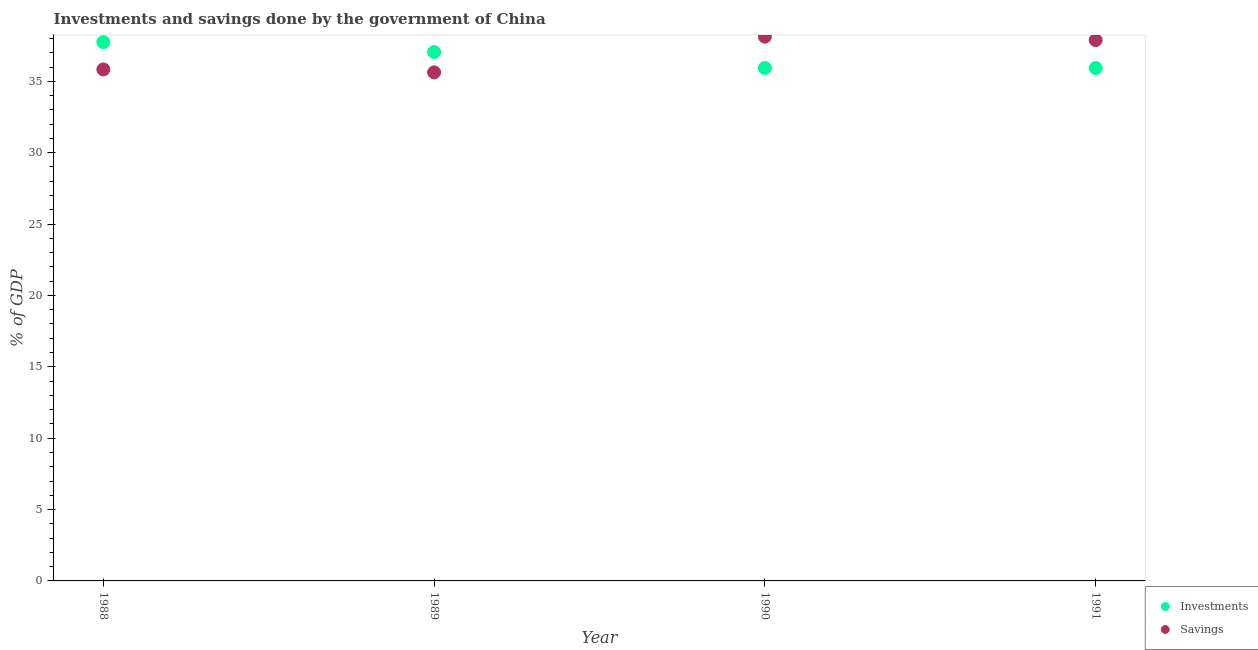What is the investments of government in 1988?
Keep it short and to the point. 37.75. Across all years, what is the maximum investments of government?
Keep it short and to the point. 37.75. Across all years, what is the minimum investments of government?
Provide a short and direct response. 35.93. In which year was the savings of government maximum?
Offer a very short reply. 1990. What is the total savings of government in the graph?
Ensure brevity in your answer.  147.48. What is the difference between the savings of government in 1989 and that in 1990?
Keep it short and to the point. -2.5. What is the difference between the savings of government in 1989 and the investments of government in 1990?
Make the answer very short. -0.31. What is the average investments of government per year?
Offer a very short reply. 36.67. In the year 1988, what is the difference between the investments of government and savings of government?
Make the answer very short. 1.91. In how many years, is the savings of government greater than 24 %?
Offer a terse response. 4. What is the ratio of the investments of government in 1988 to that in 1991?
Provide a succinct answer. 1.05. Is the savings of government in 1989 less than that in 1991?
Your answer should be very brief. Yes. What is the difference between the highest and the second highest investments of government?
Your answer should be compact. 0.69. What is the difference between the highest and the lowest investments of government?
Offer a terse response. 1.81. In how many years, is the investments of government greater than the average investments of government taken over all years?
Give a very brief answer. 2. Is the sum of the savings of government in 1988 and 1989 greater than the maximum investments of government across all years?
Offer a terse response. Yes. Does the savings of government monotonically increase over the years?
Your answer should be very brief. No. Is the savings of government strictly greater than the investments of government over the years?
Keep it short and to the point. No. What is the difference between two consecutive major ticks on the Y-axis?
Offer a terse response. 5. Are the values on the major ticks of Y-axis written in scientific E-notation?
Ensure brevity in your answer.  No. Does the graph contain grids?
Provide a succinct answer. No. How many legend labels are there?
Provide a succinct answer. 2. What is the title of the graph?
Provide a succinct answer. Investments and savings done by the government of China. What is the label or title of the Y-axis?
Provide a succinct answer. % of GDP. What is the % of GDP of Investments in 1988?
Ensure brevity in your answer.  37.75. What is the % of GDP of Savings in 1988?
Provide a succinct answer. 35.84. What is the % of GDP in Investments in 1989?
Make the answer very short. 37.05. What is the % of GDP of Savings in 1989?
Offer a very short reply. 35.63. What is the % of GDP in Investments in 1990?
Your answer should be very brief. 35.94. What is the % of GDP in Savings in 1990?
Your response must be concise. 38.13. What is the % of GDP of Investments in 1991?
Provide a succinct answer. 35.93. What is the % of GDP in Savings in 1991?
Your answer should be very brief. 37.89. Across all years, what is the maximum % of GDP in Investments?
Your response must be concise. 37.75. Across all years, what is the maximum % of GDP of Savings?
Your answer should be compact. 38.13. Across all years, what is the minimum % of GDP in Investments?
Your response must be concise. 35.93. Across all years, what is the minimum % of GDP in Savings?
Offer a very short reply. 35.63. What is the total % of GDP in Investments in the graph?
Keep it short and to the point. 146.67. What is the total % of GDP in Savings in the graph?
Give a very brief answer. 147.48. What is the difference between the % of GDP in Investments in 1988 and that in 1989?
Keep it short and to the point. 0.69. What is the difference between the % of GDP of Savings in 1988 and that in 1989?
Your answer should be very brief. 0.21. What is the difference between the % of GDP in Investments in 1988 and that in 1990?
Give a very brief answer. 1.81. What is the difference between the % of GDP in Savings in 1988 and that in 1990?
Offer a very short reply. -2.29. What is the difference between the % of GDP in Investments in 1988 and that in 1991?
Give a very brief answer. 1.81. What is the difference between the % of GDP of Savings in 1988 and that in 1991?
Offer a very short reply. -2.06. What is the difference between the % of GDP of Investments in 1989 and that in 1990?
Provide a short and direct response. 1.12. What is the difference between the % of GDP in Savings in 1989 and that in 1990?
Make the answer very short. -2.5. What is the difference between the % of GDP in Investments in 1989 and that in 1991?
Your answer should be compact. 1.12. What is the difference between the % of GDP in Savings in 1989 and that in 1991?
Your response must be concise. -2.26. What is the difference between the % of GDP of Investments in 1990 and that in 1991?
Ensure brevity in your answer.  0. What is the difference between the % of GDP in Savings in 1990 and that in 1991?
Your response must be concise. 0.24. What is the difference between the % of GDP in Investments in 1988 and the % of GDP in Savings in 1989?
Your answer should be very brief. 2.12. What is the difference between the % of GDP in Investments in 1988 and the % of GDP in Savings in 1990?
Give a very brief answer. -0.38. What is the difference between the % of GDP in Investments in 1988 and the % of GDP in Savings in 1991?
Provide a succinct answer. -0.14. What is the difference between the % of GDP in Investments in 1989 and the % of GDP in Savings in 1990?
Offer a very short reply. -1.07. What is the difference between the % of GDP in Investments in 1989 and the % of GDP in Savings in 1991?
Ensure brevity in your answer.  -0.84. What is the difference between the % of GDP of Investments in 1990 and the % of GDP of Savings in 1991?
Keep it short and to the point. -1.95. What is the average % of GDP of Investments per year?
Provide a short and direct response. 36.67. What is the average % of GDP of Savings per year?
Your answer should be compact. 36.87. In the year 1988, what is the difference between the % of GDP in Investments and % of GDP in Savings?
Offer a terse response. 1.91. In the year 1989, what is the difference between the % of GDP of Investments and % of GDP of Savings?
Your answer should be very brief. 1.43. In the year 1990, what is the difference between the % of GDP in Investments and % of GDP in Savings?
Give a very brief answer. -2.19. In the year 1991, what is the difference between the % of GDP of Investments and % of GDP of Savings?
Offer a terse response. -1.96. What is the ratio of the % of GDP of Investments in 1988 to that in 1989?
Ensure brevity in your answer.  1.02. What is the ratio of the % of GDP in Savings in 1988 to that in 1989?
Provide a succinct answer. 1.01. What is the ratio of the % of GDP of Investments in 1988 to that in 1990?
Give a very brief answer. 1.05. What is the ratio of the % of GDP in Savings in 1988 to that in 1990?
Your answer should be very brief. 0.94. What is the ratio of the % of GDP in Investments in 1988 to that in 1991?
Your answer should be very brief. 1.05. What is the ratio of the % of GDP in Savings in 1988 to that in 1991?
Ensure brevity in your answer.  0.95. What is the ratio of the % of GDP in Investments in 1989 to that in 1990?
Make the answer very short. 1.03. What is the ratio of the % of GDP of Savings in 1989 to that in 1990?
Your answer should be compact. 0.93. What is the ratio of the % of GDP in Investments in 1989 to that in 1991?
Provide a short and direct response. 1.03. What is the ratio of the % of GDP in Savings in 1989 to that in 1991?
Ensure brevity in your answer.  0.94. What is the ratio of the % of GDP of Investments in 1990 to that in 1991?
Offer a very short reply. 1. What is the difference between the highest and the second highest % of GDP in Investments?
Offer a very short reply. 0.69. What is the difference between the highest and the second highest % of GDP of Savings?
Ensure brevity in your answer.  0.24. What is the difference between the highest and the lowest % of GDP of Investments?
Keep it short and to the point. 1.81. What is the difference between the highest and the lowest % of GDP of Savings?
Your response must be concise. 2.5. 